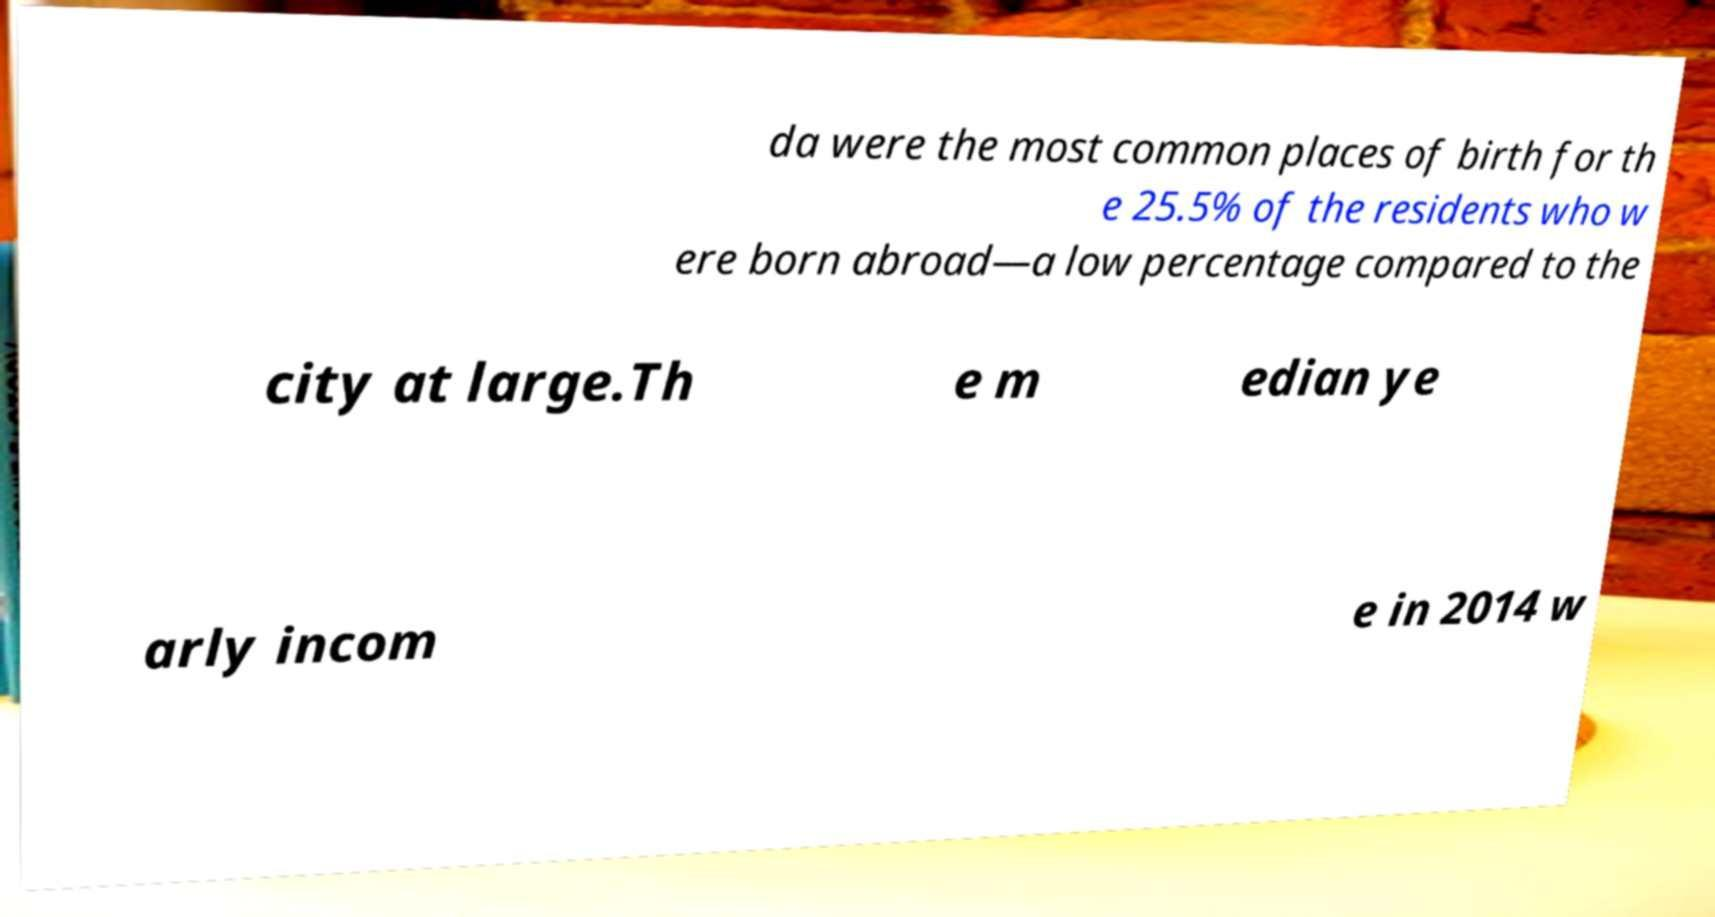Can you accurately transcribe the text from the provided image for me? da were the most common places of birth for th e 25.5% of the residents who w ere born abroad—a low percentage compared to the city at large.Th e m edian ye arly incom e in 2014 w 